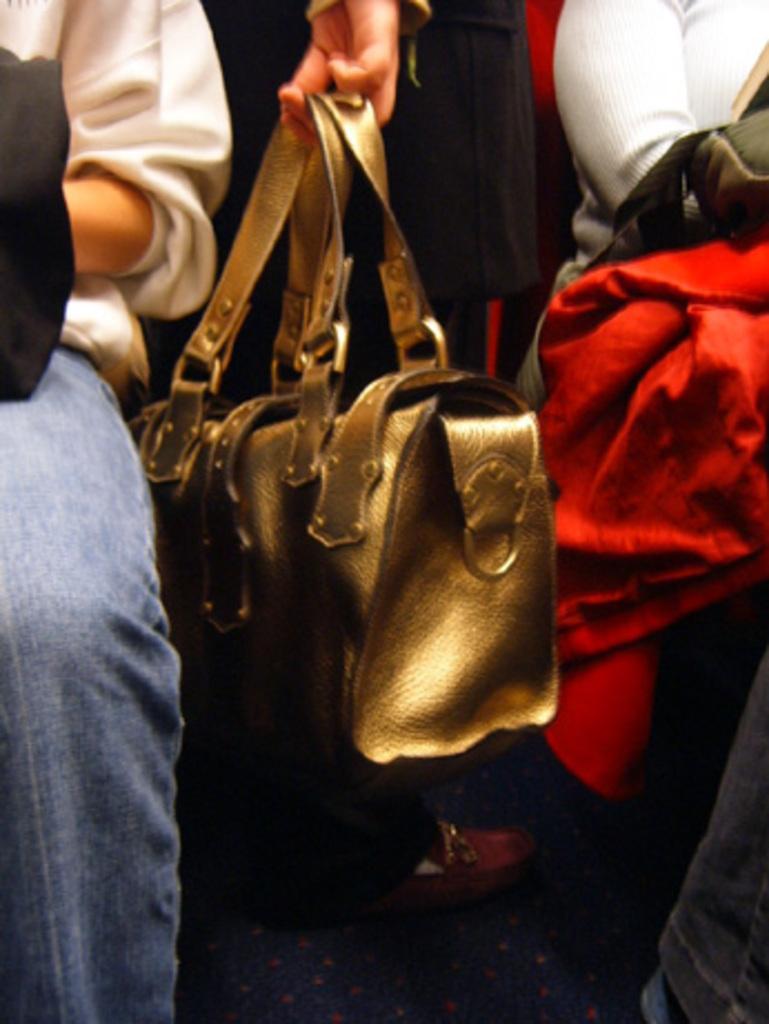Describe this image in one or two sentences. In this image in the middle there is a woman she is holding a bag. On the left there is a person. On the right there is a person and red jacket, bag. 